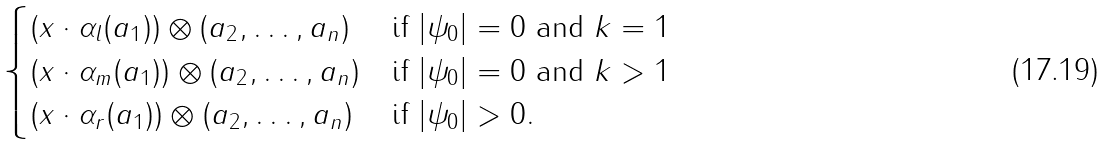<formula> <loc_0><loc_0><loc_500><loc_500>\begin{cases} ( x \cdot \alpha _ { l } ( a _ { 1 } ) ) \otimes ( a _ { 2 } , \dots , a _ { n } ) & \text {if } | \psi _ { 0 } | = 0 \text { and } k = 1 \\ ( x \cdot \alpha _ { m } ( a _ { 1 } ) ) \otimes ( a _ { 2 } , \dots , a _ { n } ) & \text {if } | \psi _ { 0 } | = 0 \text { and } k > 1 \\ ( x \cdot \alpha _ { r } ( a _ { 1 } ) ) \otimes ( a _ { 2 } , \dots , a _ { n } ) & \text {if } | \psi _ { 0 } | > 0 . \end{cases}</formula> 